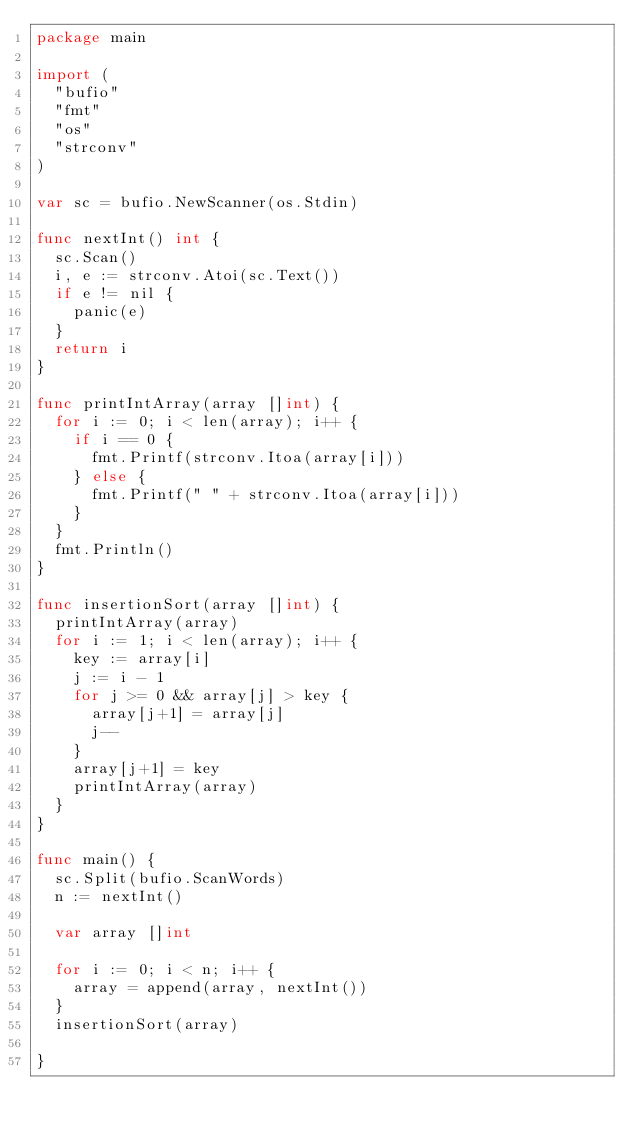<code> <loc_0><loc_0><loc_500><loc_500><_Go_>package main

import (
	"bufio"
	"fmt"
	"os"
	"strconv"
)

var sc = bufio.NewScanner(os.Stdin)

func nextInt() int {
	sc.Scan()
	i, e := strconv.Atoi(sc.Text())
	if e != nil {
		panic(e)
	}
	return i
}

func printIntArray(array []int) {
	for i := 0; i < len(array); i++ {
		if i == 0 {
			fmt.Printf(strconv.Itoa(array[i]))
		} else {
			fmt.Printf(" " + strconv.Itoa(array[i]))
		}
	}
	fmt.Println()
}

func insertionSort(array []int) {
	printIntArray(array)
	for i := 1; i < len(array); i++ {
		key := array[i]
		j := i - 1
		for j >= 0 && array[j] > key {
			array[j+1] = array[j]
			j--
		}
		array[j+1] = key
		printIntArray(array)
	}
}

func main() {
	sc.Split(bufio.ScanWords)
	n := nextInt()

	var array []int

	for i := 0; i < n; i++ {
		array = append(array, nextInt())
	}
	insertionSort(array)

}

</code> 